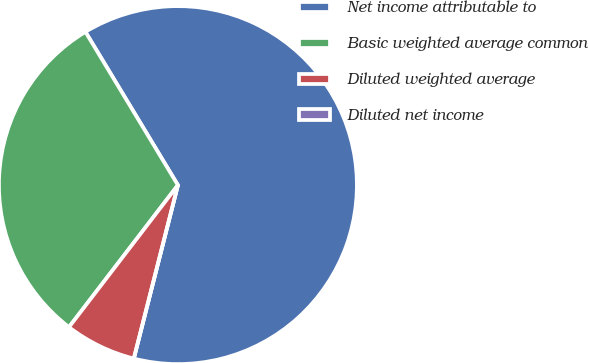Convert chart. <chart><loc_0><loc_0><loc_500><loc_500><pie_chart><fcel>Net income attributable to<fcel>Basic weighted average common<fcel>Diluted weighted average<fcel>Diluted net income<nl><fcel>62.61%<fcel>30.95%<fcel>6.45%<fcel>0.0%<nl></chart> 